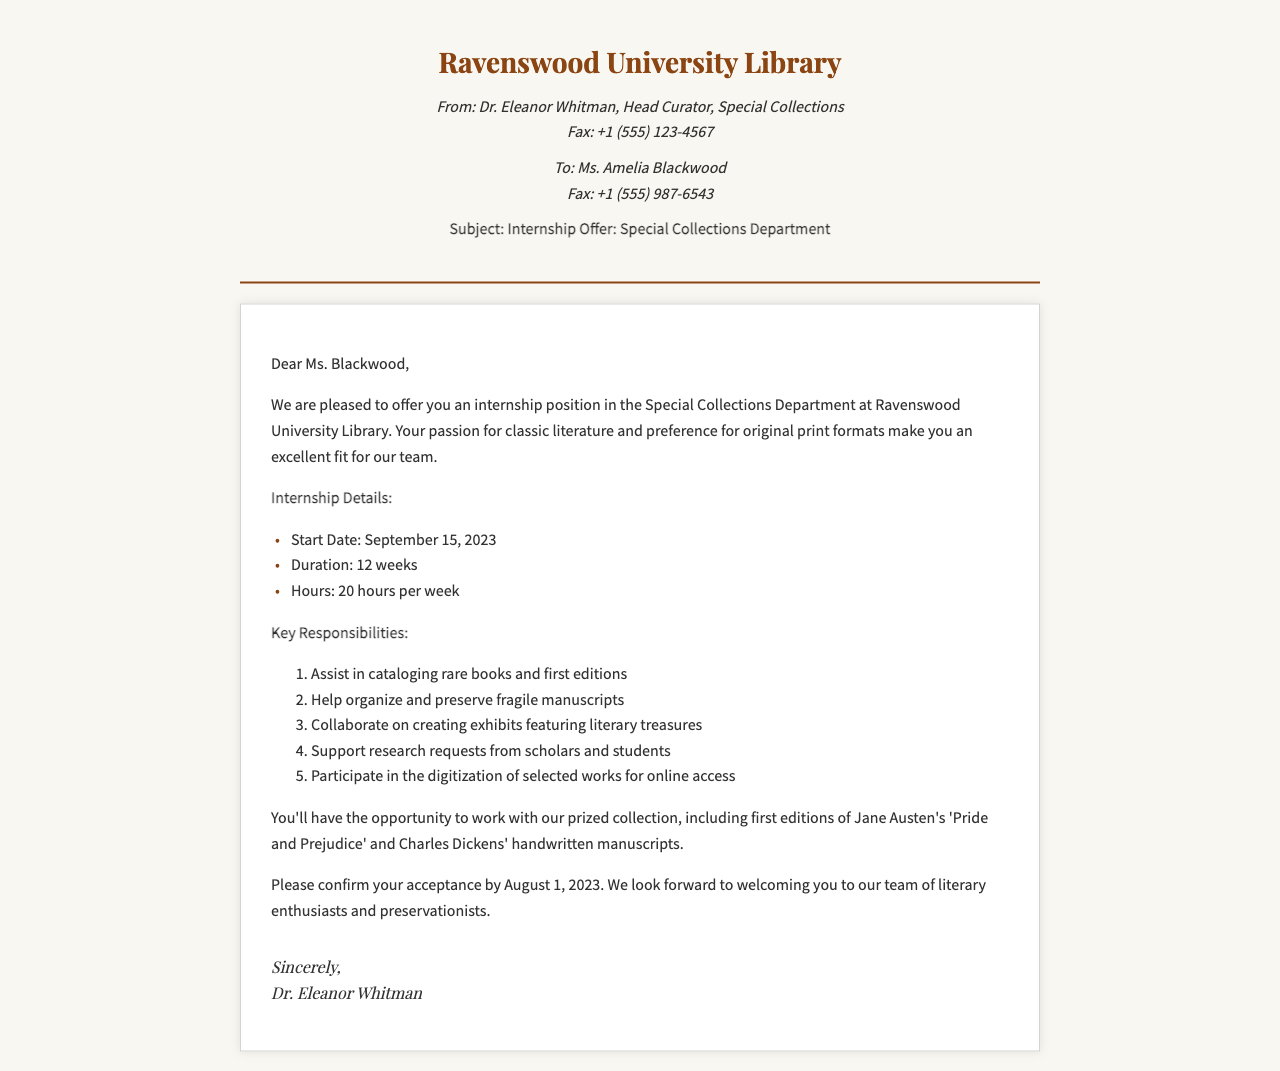What is the start date of the internship? The start date is specified in the internship details section of the document.
Answer: September 15, 2023 How long is the duration of the internship? The duration is mentioned in the internship details, which states how long the internship will last.
Answer: 12 weeks What is the weekly hour commitment for the internship? The number of hours required per week is outlined in the internship details.
Answer: 20 hours Who is the sender of the fax? The sender's name and title are found at the top of the document in the sender info section.
Answer: Dr. Eleanor Whitman What is one responsibility of the internship? The key responsibilities are listed, and one specific responsibility can be chosen from that list.
Answer: Assist in cataloging rare books and first editions By what date must the recipient confirm acceptance? The confirmation date is mentioned towards the end of the fax.
Answer: August 1, 2023 Which department is offering the internship? The department offering the internship is indicated in the subject line of the fax.
Answer: Special Collections Department What is the primary focus of the internship related to the recipient's interests? The focus is specified in the introduction, highlighting the recipient's passion.
Answer: Classic literature What type of document is this? The nature of the document is evident from its structure and content.
Answer: Fax 